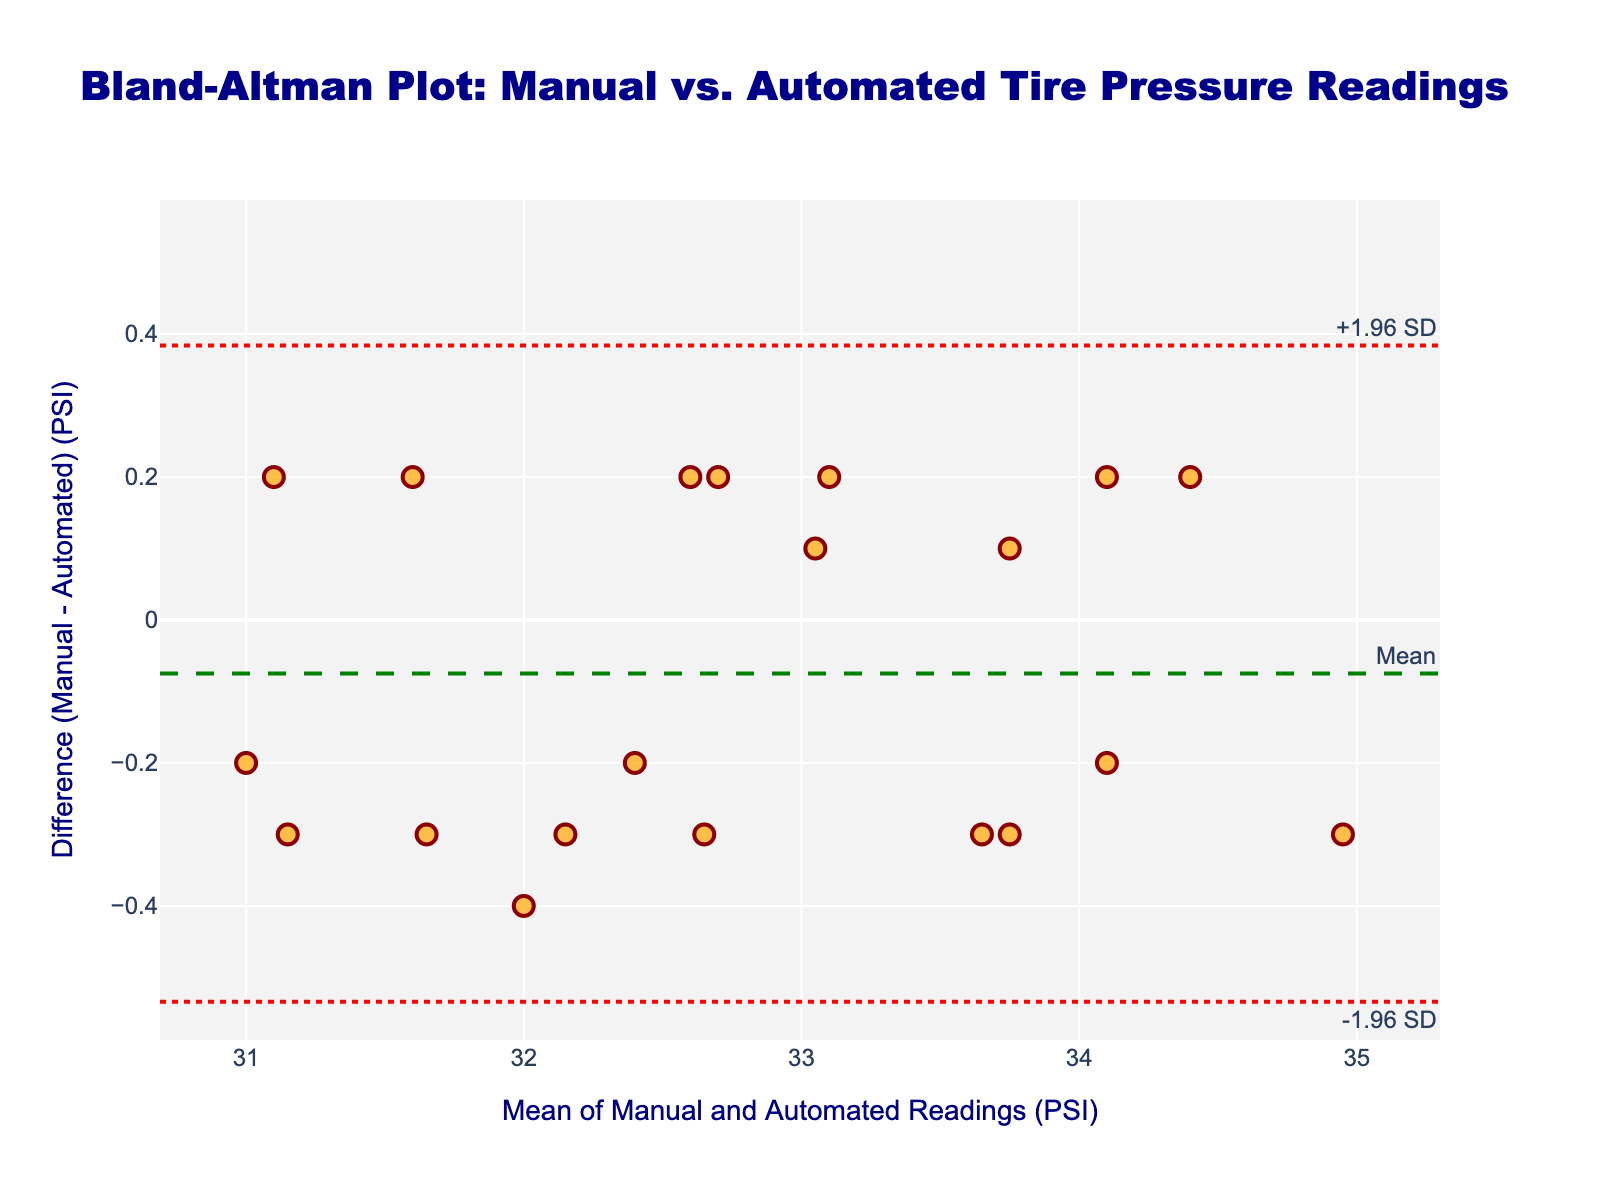What's the title of the figure? The title of a figure is usually placed at the top in a larger, bold font for easy identification. Here, the title is clearly displayed.
Answer: Bland-Altman Plot: Manual vs. Automated Tire Pressure Readings What do the x-axis and y-axis represent? The x-axis and y-axis labels provide information about what each axis measures.
Answer: The x-axis represents the mean of Manual and Automated Readings (PSI), and the y-axis represents the difference (Manual - Automated) (PSI) How many data points are plotted in the figure? Each data point represents a pair of manual and automated readings. Visually count the number of points plotted.
Answer: 20 What is the mean difference between the manual and automated readings? The mean difference is indicated by a dashed green line with a label.
Answer: Approximately 0.01 PSI What are the approximate values for the upper and lower limits of agreement? The upper and lower limits of agreement are represented by the red dotted lines labeled "+1.96 SD" and "-1.96 SD", respectively.
Answer: Approximately 0.50 PSI and -0.48 PSI How many data points lie outside the limits of agreement? Identify the data points that fall above the upper limit of agreement or below the lower limit of agreement.
Answer: 0 What color is used for the data points on the plot? The color of the data points provides an immediate visual cue and can be observed directly.
Answer: Orange Based on the plot, do manual and automated readings generally agree? Assess how close and how consistent the data points are around the mean difference and within the limits of agreement.
Answer: Yes, they generally agree Are there more data points above or below the mean difference line? Visually count the data points above and below the dashed green mean difference line to determine if there is an imbalance.
Answer: About the same number of data points above and below the mean line What is the range of the mean values of manual and automated readings? The x-axis represents the mean values of manual and automated readings. Identify the minimum and maximum values from the plot.
Answer: Approximately 31 PSI to 34.5 PSI 